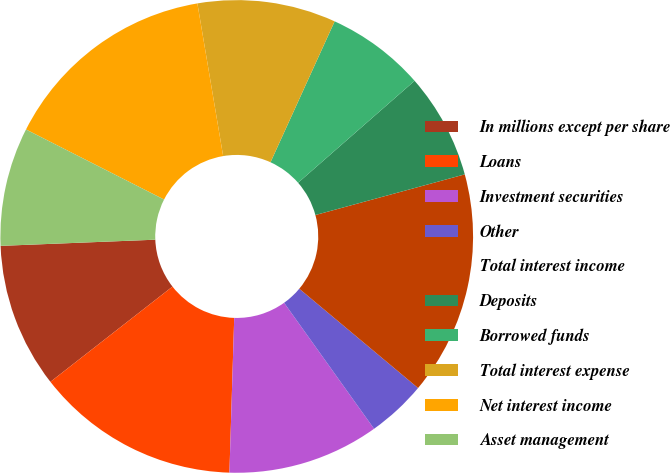Convert chart to OTSL. <chart><loc_0><loc_0><loc_500><loc_500><pie_chart><fcel>In millions except per share<fcel>Loans<fcel>Investment securities<fcel>Other<fcel>Total interest income<fcel>Deposits<fcel>Borrowed funds<fcel>Total interest expense<fcel>Net interest income<fcel>Asset management<nl><fcel>9.91%<fcel>13.96%<fcel>10.36%<fcel>4.05%<fcel>15.31%<fcel>7.21%<fcel>6.76%<fcel>9.46%<fcel>14.86%<fcel>8.11%<nl></chart> 